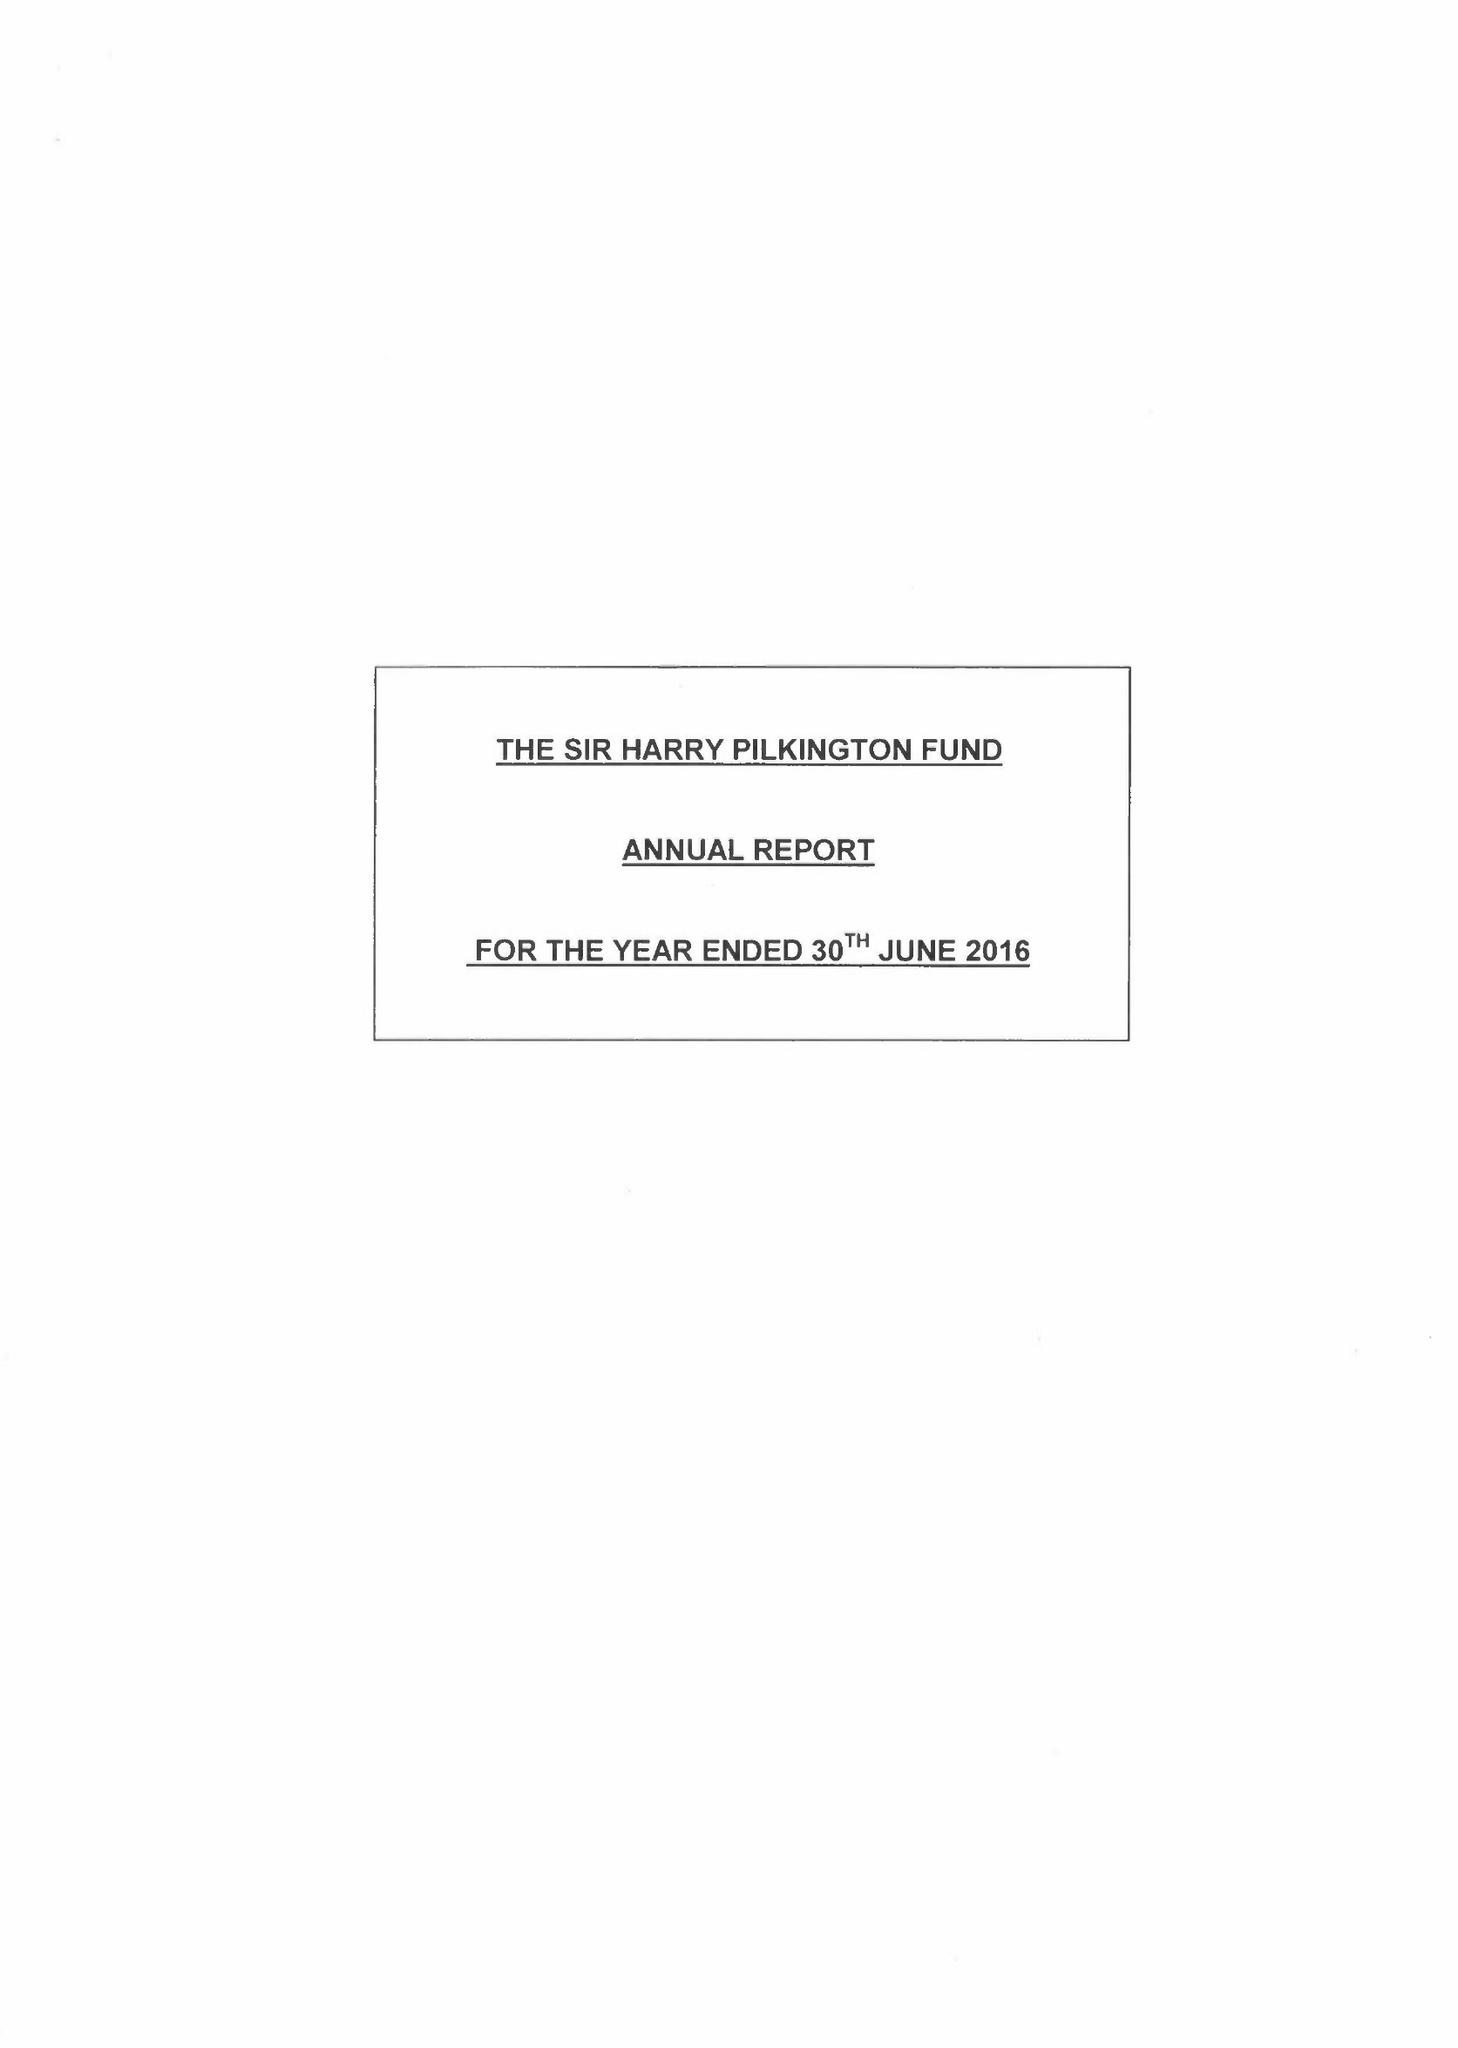What is the value for the address__postcode?
Answer the question using a single word or phrase. L2 2AH 